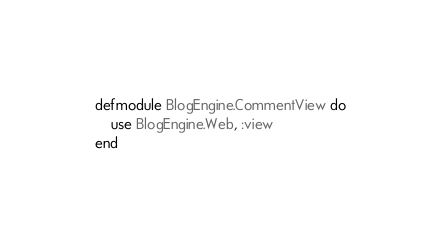Convert code to text. <code><loc_0><loc_0><loc_500><loc_500><_Elixir_>defmodule BlogEngine.CommentView do
    use BlogEngine.Web, :view
end
</code> 